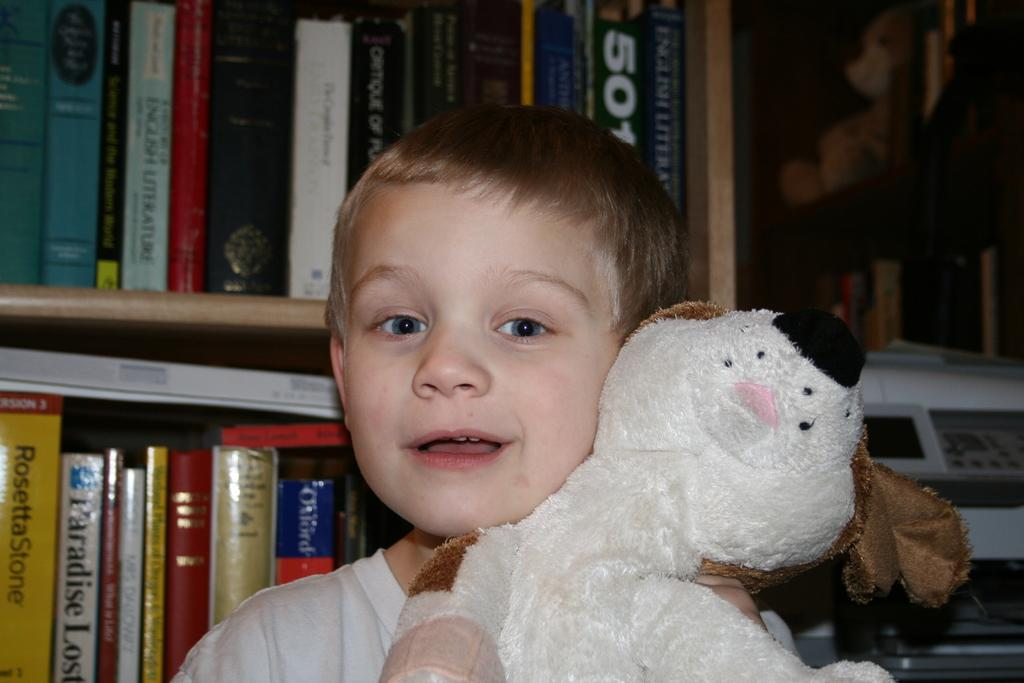Who is the main subject in the image? There is a boy in the image. What is the boy holding in the image? The boy is holding a teddy bear. What can be seen in the background of the image? There is a rack in the background of the image. What items are visible on the rack? There are books visible on the rack, and there is a teddy bear visible on the right side of the rack. What type of horn can be heard in the image? There is no horn present in the image, and therefore no sound can be heard. 